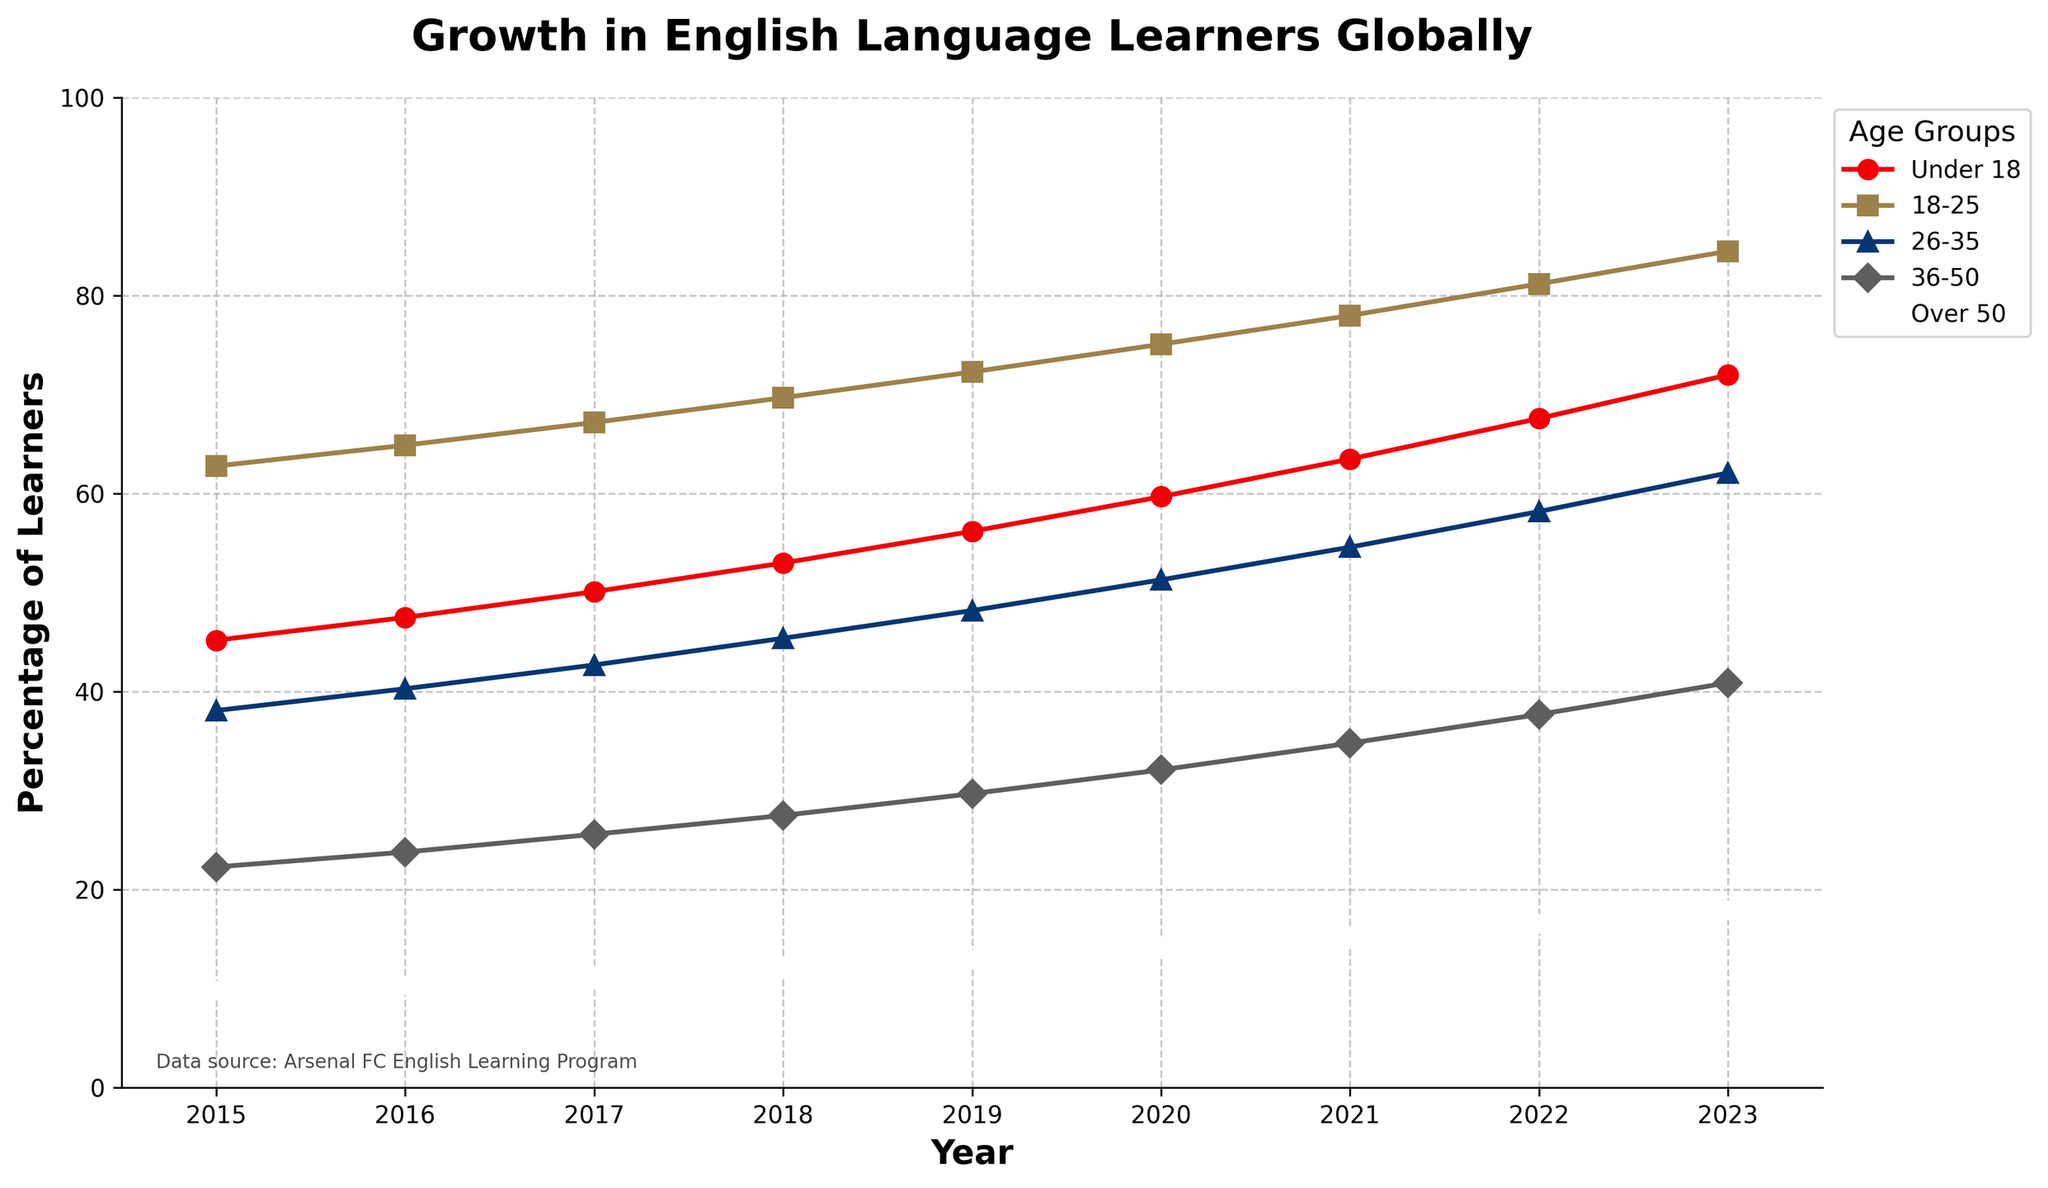What's the most significant increase in the percentage of learners in any age group from 2015 to 2023? To find the most significant increase, calculate the difference between the percentages in 2023 and 2015 for each age group. The differences are:
Under 18: 72.0 - 45.2 = 26.8
18-25: 84.5 - 62.8 = 21.7
26-35: 62.1 - 38.1 = 24.0
36-50: 40.9 - 22.3 = 18.6
Over 50: 17.8 - 9.7 = 8.1. The largest increase is for the Under 18 group
Answer: Under 18: 26.8 Which age group had the smallest increase in the percentage of learners from 2015 to 2023? Calculate the difference between the percentages in 2023 and 2015 for each age group. The differences are:
Under 18: 26.8
18-25: 21.7
26-35: 24.0
36-50: 18.6
Over 50: 8.1. The smallest increase is for the Over 50 group
Answer: Over 50: 8.1 Which year did the 18-25 age group first surpass 75%? Identify the year when the 18-25 age group first exceeds 75%. By examining the data, we see this occurs in 2020 with a percentage of 75.1
Answer: 2020 How does the growth rate of the 36-50 age group compare to the 26-35 age group from 2015 to 2023? Calculate the growth rate for each age group from 2015 to 2023. The 36-50 age group increases from 22.3 to 40.9, so the growth rate is (40.9 - 22.3) / 22.3 ≈ 0.835. The 26-35 age group increases from 38.1 to 62.1, so the growth rate is (62.1 - 38.1) / 38.1 ≈ 0.63. Thus, the 36-50 age group has a higher growth rate
Answer: 36-50 group has a higher growth rate For which age group is the percentage of learners closest during 2020? By comparing the percentages in 2020, we have:
Under 18: 59.7
18-25: 75.1
26-35: 51.3
36-50: 32.1
Over 50: 13.9. The percentages of Under 18 and 26-35 are closest, with a difference of
Answer: Under 18 and 26-35: 8.4 Which age group had consistent growth every year from 2015 to 2023? Analyze each age group's data to see if their percentage increases every year. Based on visual inspection, all age groups show consistent growth every year
Answer: All age groups had consistent growth Between which consecutive years did the Under 18 group experience the highest percentage increase? Find the year with the largest difference in Under 18 between consecutive years:
2015-2016: 47.5 - 45.2 = 2.3
2016-2017: 50.1 - 47.5 = 2.6
2017-2018: 53.0 - 50.1 = 2.9
2018-2019: 56.2 - 53.0 = 3.2
2019-2020: 59.7 - 56.2 = 3.5
2020-2021: 63.5 - 59.7 = 3.8
2021-2022: 67.6 - 63.5 = 4.1
2022-2023: 72.0 - 67.6 = 4.4. The largest increase is from 2022 to 2023
Answer: From 2022 to 2023 